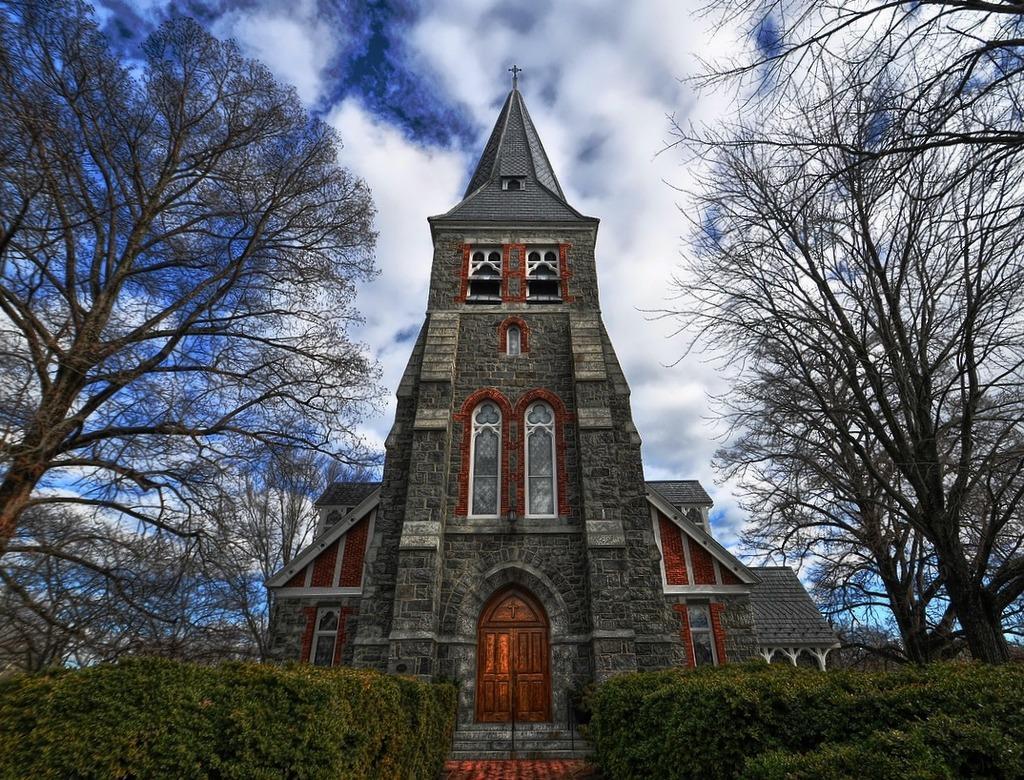Could you give a brief overview of what you see in this image? In the picture we can see a church building with a door and besides it, we can see bushes and trees on the sides and behind it we can see the sky with clouds. 